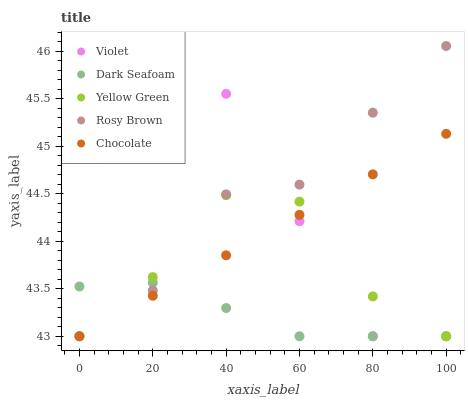Does Dark Seafoam have the minimum area under the curve?
Answer yes or no. Yes. Does Violet have the maximum area under the curve?
Answer yes or no. Yes. Does Rosy Brown have the minimum area under the curve?
Answer yes or no. No. Does Rosy Brown have the maximum area under the curve?
Answer yes or no. No. Is Chocolate the smoothest?
Answer yes or no. Yes. Is Violet the roughest?
Answer yes or no. Yes. Is Dark Seafoam the smoothest?
Answer yes or no. No. Is Dark Seafoam the roughest?
Answer yes or no. No. Does Chocolate have the lowest value?
Answer yes or no. Yes. Does Rosy Brown have the highest value?
Answer yes or no. Yes. Does Dark Seafoam have the highest value?
Answer yes or no. No. Does Violet intersect Chocolate?
Answer yes or no. Yes. Is Violet less than Chocolate?
Answer yes or no. No. Is Violet greater than Chocolate?
Answer yes or no. No. 